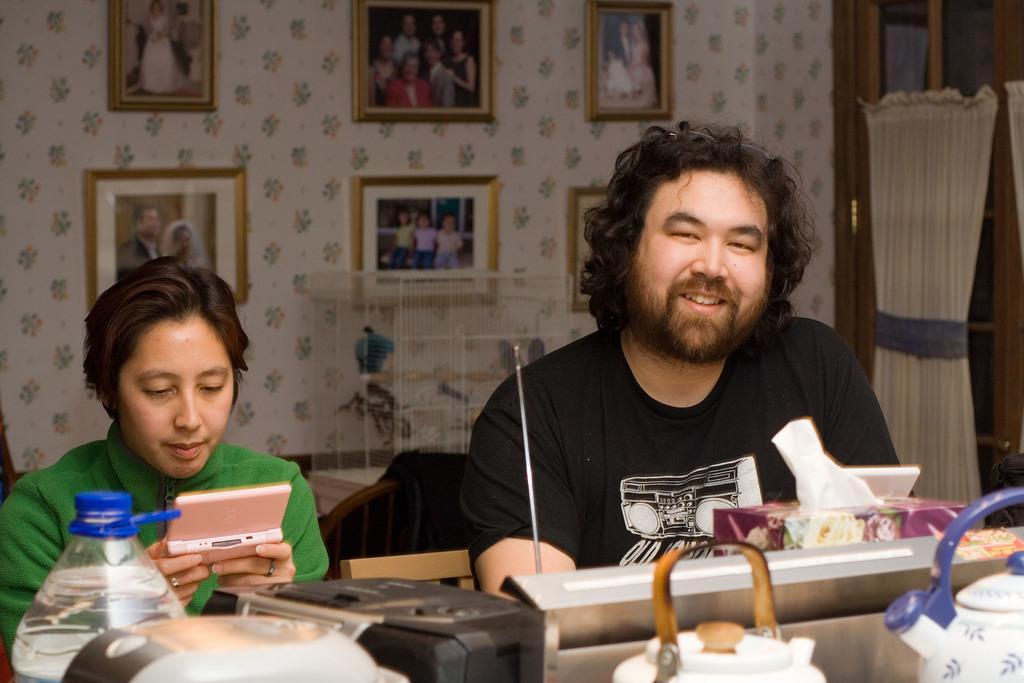In one or two sentences, can you explain what this image depicts? On the background we can see photo frames over a decorative wall. Here we can see two persons sitting on chairs in front of a table and on the table we can see bottle, kettles, music player, radio tape, tissue paper box. At the right side of the picture we can see a door. 